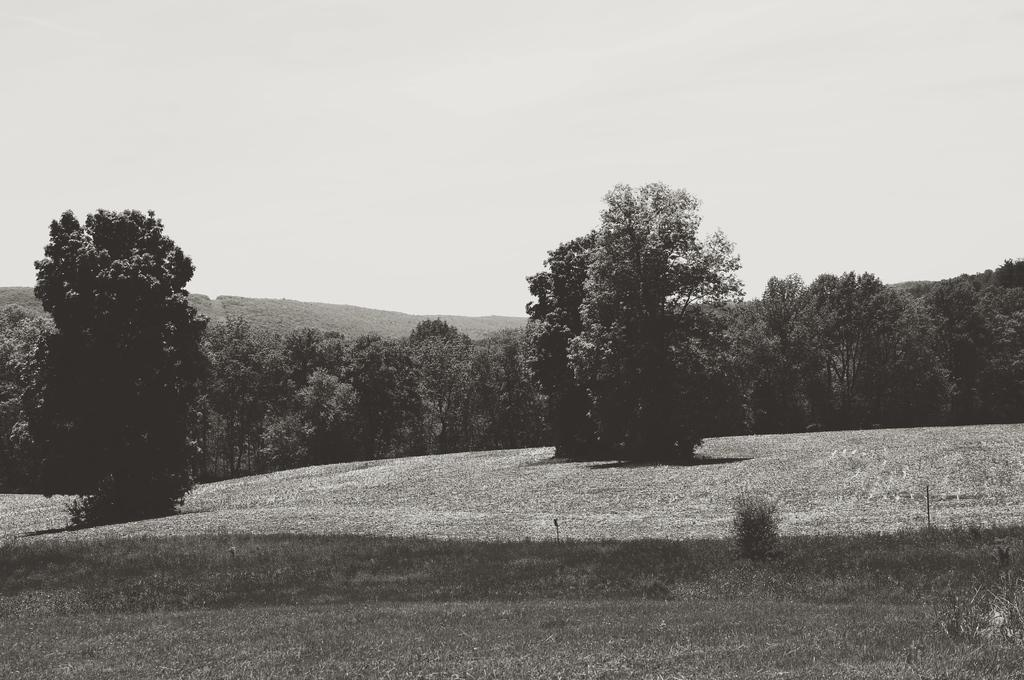What is the color scheme of the image? The image is black and white. What type of vegetation can be seen in the image? There are trees, plants, and grass visible in the image. What part of the natural environment is visible in the image? The sky is visible in the image. What type of curtain can be seen hanging from the trees in the image? There are no curtains present in the image; it features natural elements such as trees, plants, grass, and the sky. 